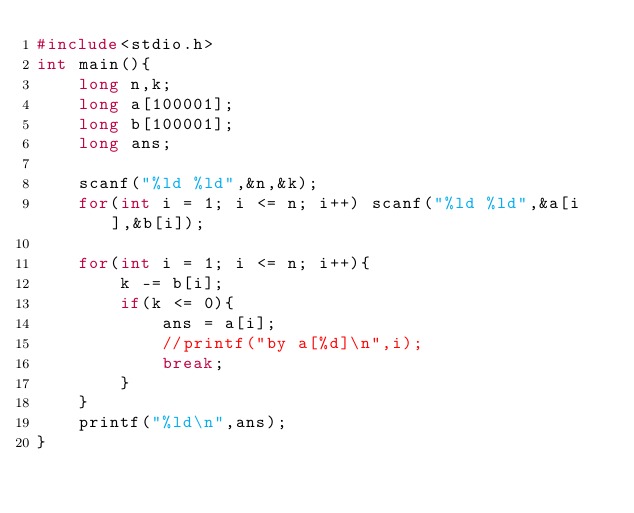<code> <loc_0><loc_0><loc_500><loc_500><_C_>#include<stdio.h>
int main(){
    long n,k;
    long a[100001];
    long b[100001];
    long ans;
    
    scanf("%ld %ld",&n,&k);
    for(int i = 1; i <= n; i++) scanf("%ld %ld",&a[i],&b[i]);
    
    for(int i = 1; i <= n; i++){
        k -= b[i];
        if(k <= 0){
            ans = a[i];
            //printf("by a[%d]\n",i);
            break;
        }
    }
    printf("%ld\n",ans);
}
</code> 